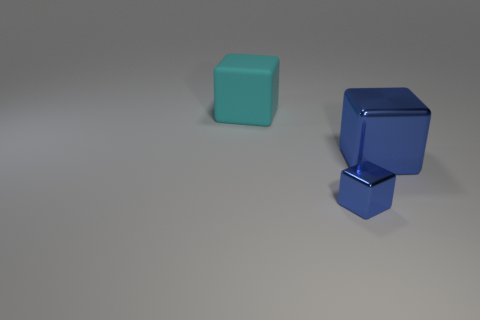Add 1 large shiny blocks. How many objects exist? 4 Subtract 0 cyan spheres. How many objects are left? 3 Subtract all purple rubber balls. Subtract all metal objects. How many objects are left? 1 Add 1 big blue shiny cubes. How many big blue shiny cubes are left? 2 Add 3 blue objects. How many blue objects exist? 5 